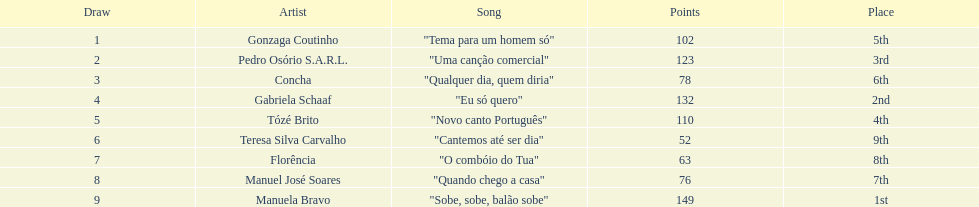Which artist came in last place? Teresa Silva Carvalho. 